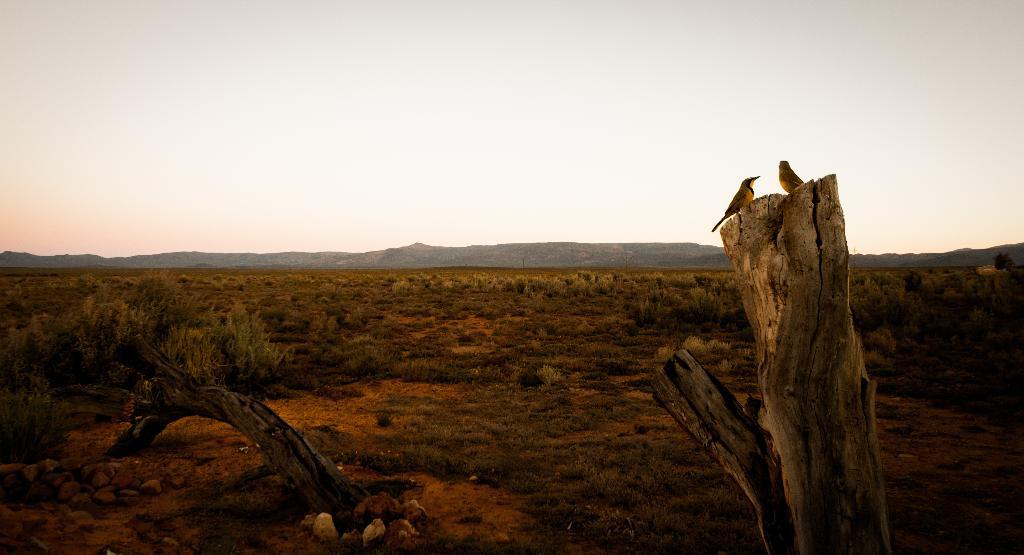What type of animals can be seen in the image? There are two barks in the image. What is on the ground in the image? There are stones on the ground in the image. What type of vegetation is present in the image? The image contains many plants and grass. What can be seen in the background of the image? There is a mountain in the background of the image. What part of the natural environment is visible in the image? The sky is visible in the image. What type of badge can be seen on the committee members in the image? There is no committee or badges present in the image; it features two barks, stones, plants, grass, a mountain, and the sky. What type of furniture can be seen in the bedroom in the image? There is no bedroom present in the image; it features two barks, stones, plants, grass, a mountain, and the sky. 